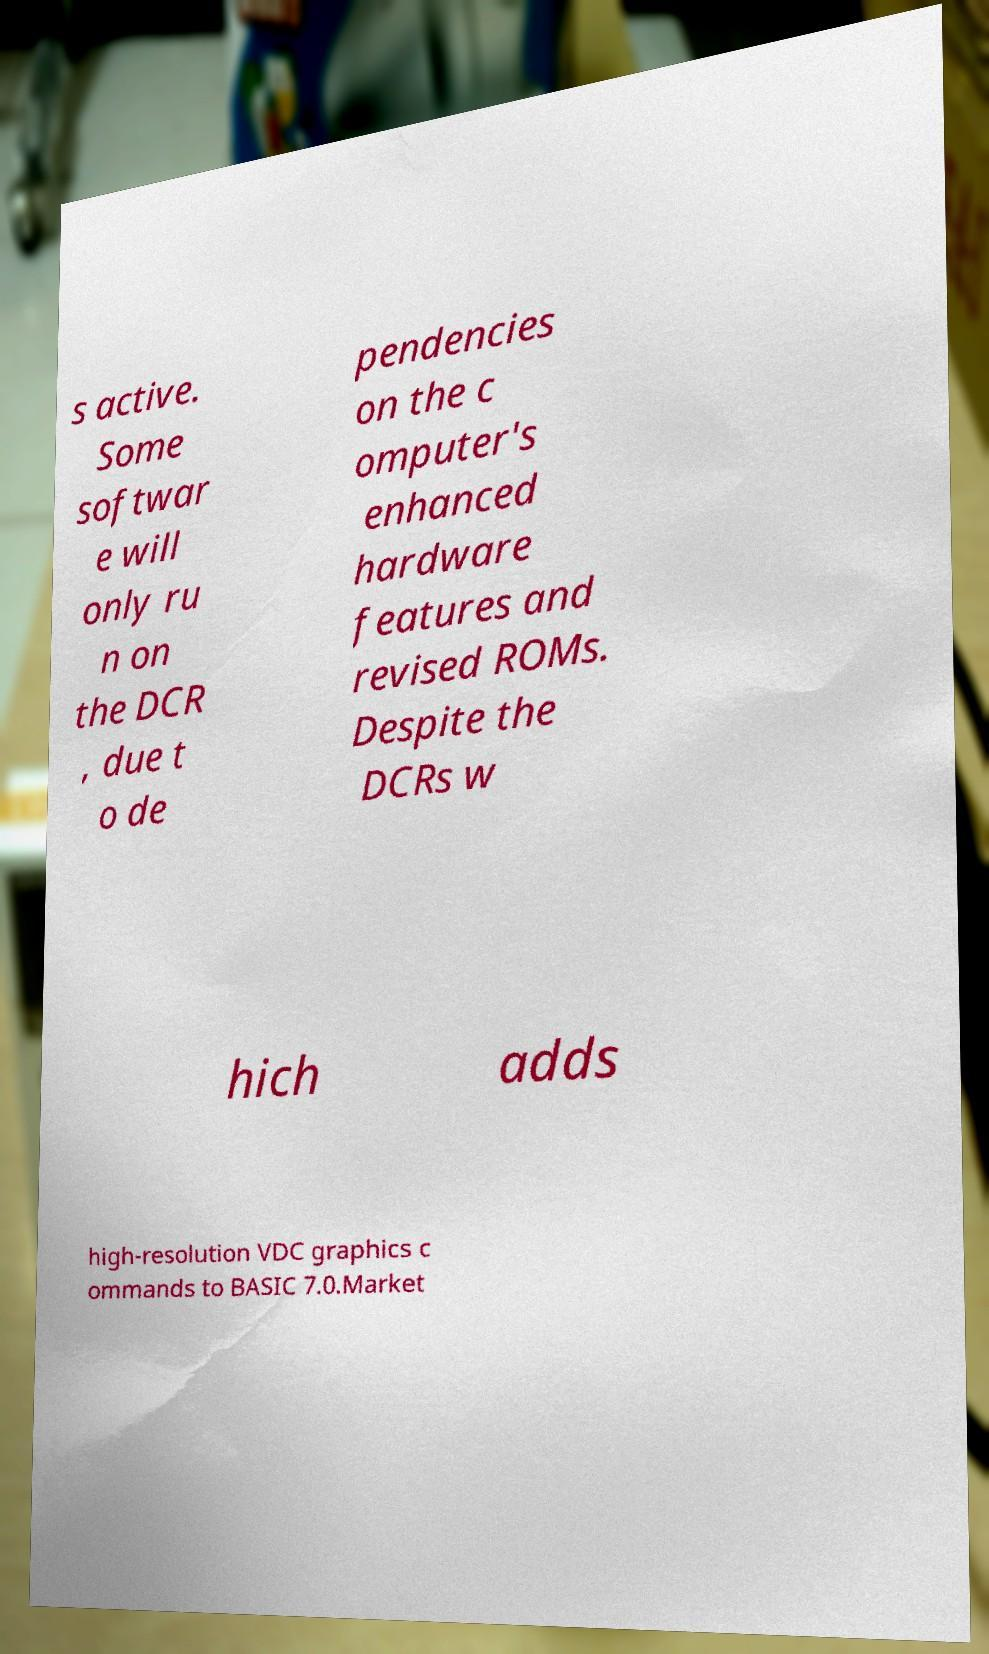I need the written content from this picture converted into text. Can you do that? s active. Some softwar e will only ru n on the DCR , due t o de pendencies on the c omputer's enhanced hardware features and revised ROMs. Despite the DCRs w hich adds high-resolution VDC graphics c ommands to BASIC 7.0.Market 